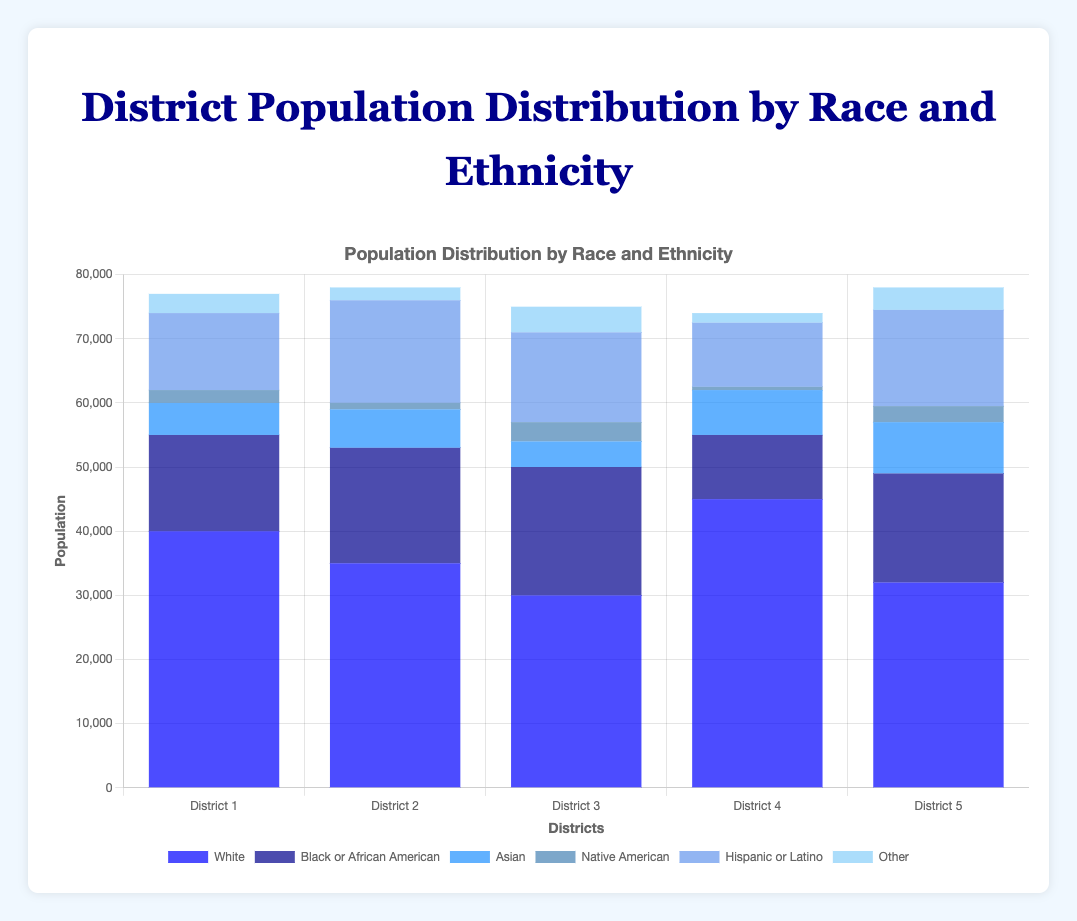Which district has the highest population of White individuals? The height of the blue bar representing the 'White' population needs to be checked for each district to determine the highest population. District 4 has the highest bar representing 45000 individuals.
Answer: District 4 How many more 'Hispanic or Latino' individuals are there in District 2 compared to District 4? Identify the 'Hispanic or Latino' population in District 2 and District 4 and calculate the difference. District 2 has 16000 individuals, and District 4 has 10000 individuals. The difference is 16000 - 10000 = 6000.
Answer: 6000 Which district has the lowest population of 'Native American' individuals? Check the height of the bars for 'Native American' in each district. District 4 has the smallest bar with a height representing 500 individuals.
Answer: District 4 Comparing 'Black or African American' populations, which district has a higher population: District 1 or District 5? District 1's 'Black or African American' population is 15000, while District 5's is 17000. Since 17000 > 15000, District 5 has a higher population.
Answer: District 5 What's the combined population of 'Asian' and 'Other' ethnicities in District 3? Sum the populations of 'Asian' and 'Other' in District 3. Asian: 4000, Other: 4000. The total is 4000 + 4000 = 8000.
Answer: 8000 Does District 1 have more 'Other' individuals than District 2? Compare the height of the 'Other' bars for District 1 and District 2. District 1 has 3000, and District 2 has 2000. Since 3000 > 2000, District 1 has more 'Other' individuals.
Answer: Yes Which district has the greatest diversity (i.e., the most evenly distributed population across all racial and ethnic categories)? Examine the bars' heights for each race and ethnicity within each district to identify the district where the bars are most similar in height.
Answer: District 3 What's the total population of District 5 across all races and ethnicities? Sum up all the populations of different races and ethnicities in District 5. 32000 + 17000 + 8000 + 2500 + 15000 + 3500 = 78000.
Answer: 78000 What's the average population of 'White' individuals across all districts? Calculate the average by summing the 'White' populations across the districts and dividing by the number of districts. Sum: 40000 + 35000 + 30000 + 45000 + 32000 = 182000. Average: 182000 / 5 = 36400.
Answer: 36400 